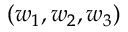Convert formula to latex. <formula><loc_0><loc_0><loc_500><loc_500>( w _ { 1 } , w _ { 2 } , w _ { 3 } )</formula> 